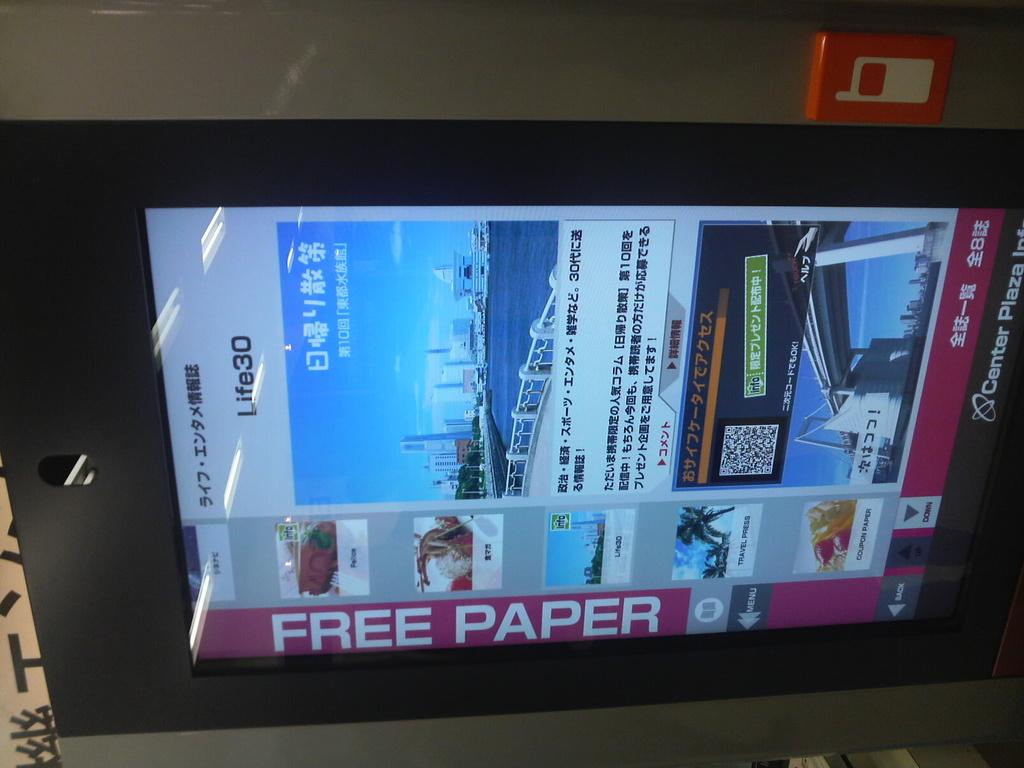Provide a one-sentence caption for the provided image. A promotional display screen indicates the opportunity for free paper along with images and words in another language. 